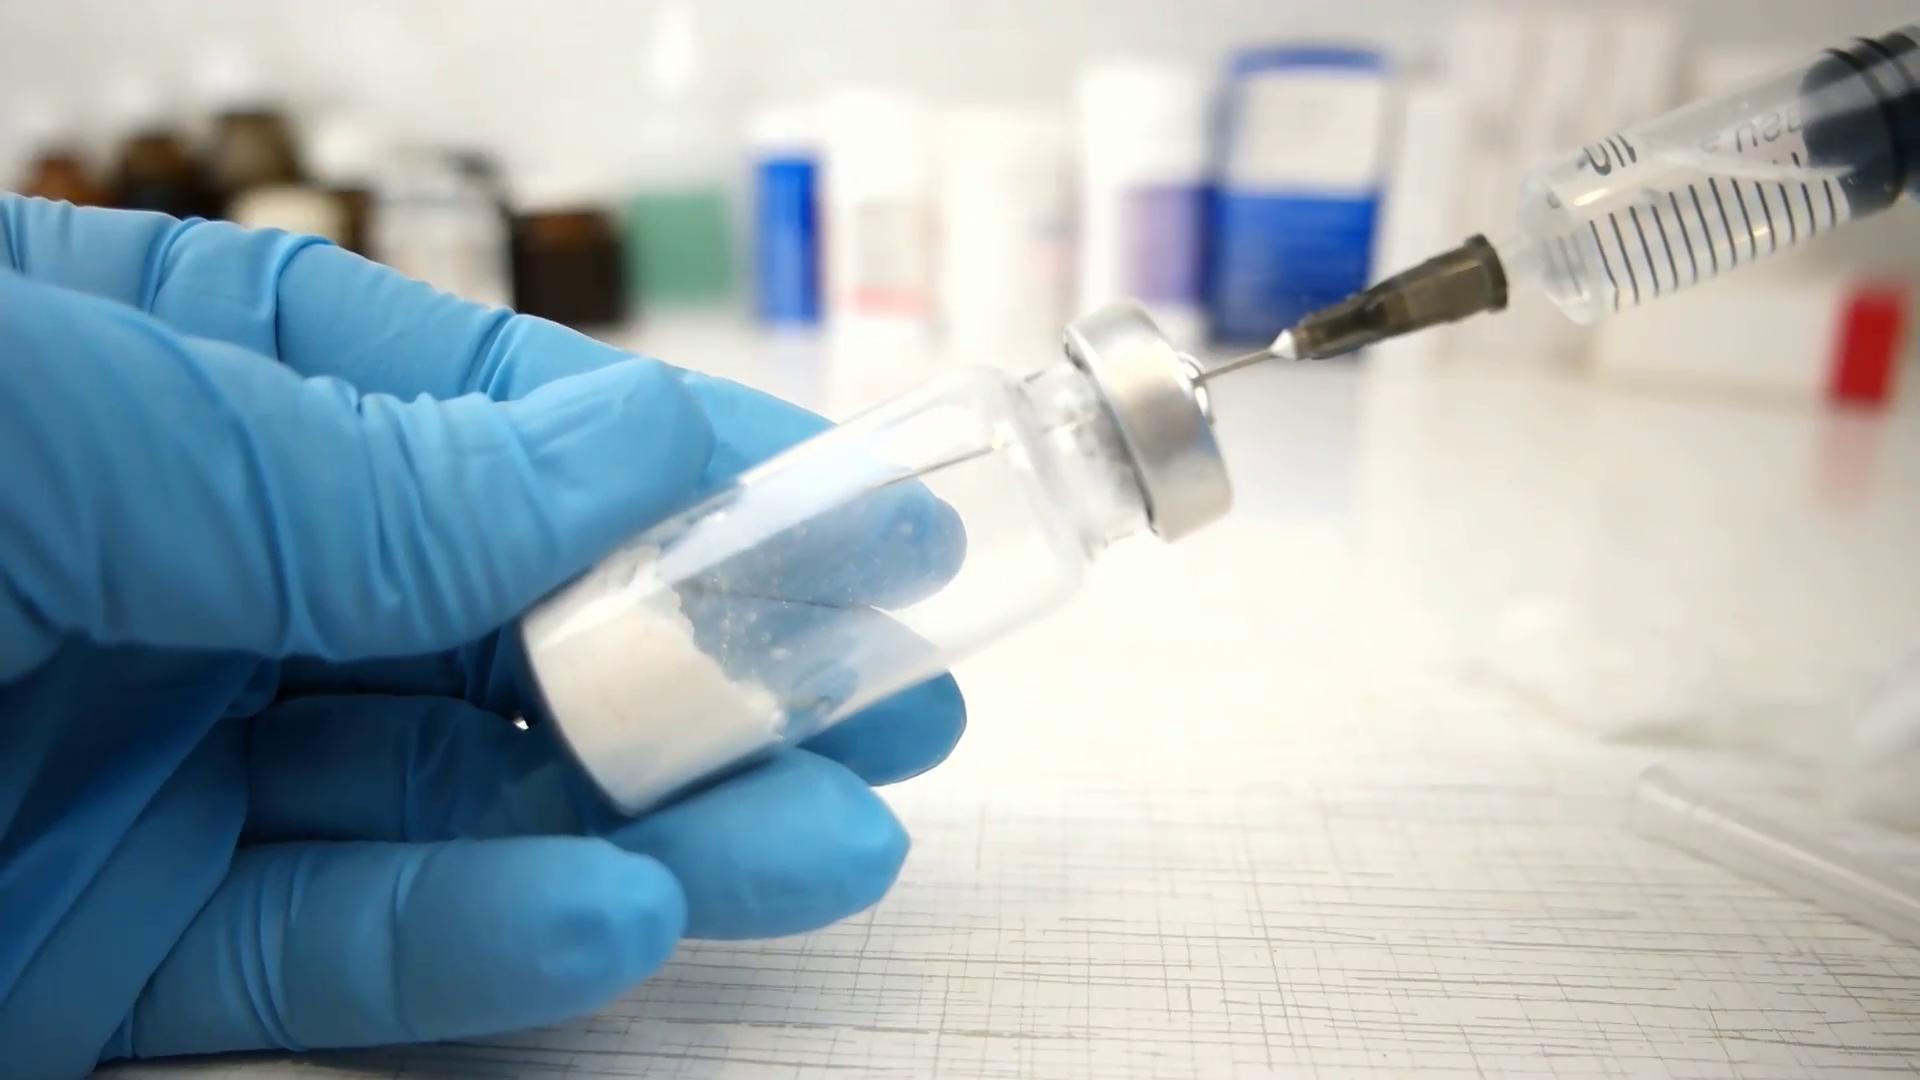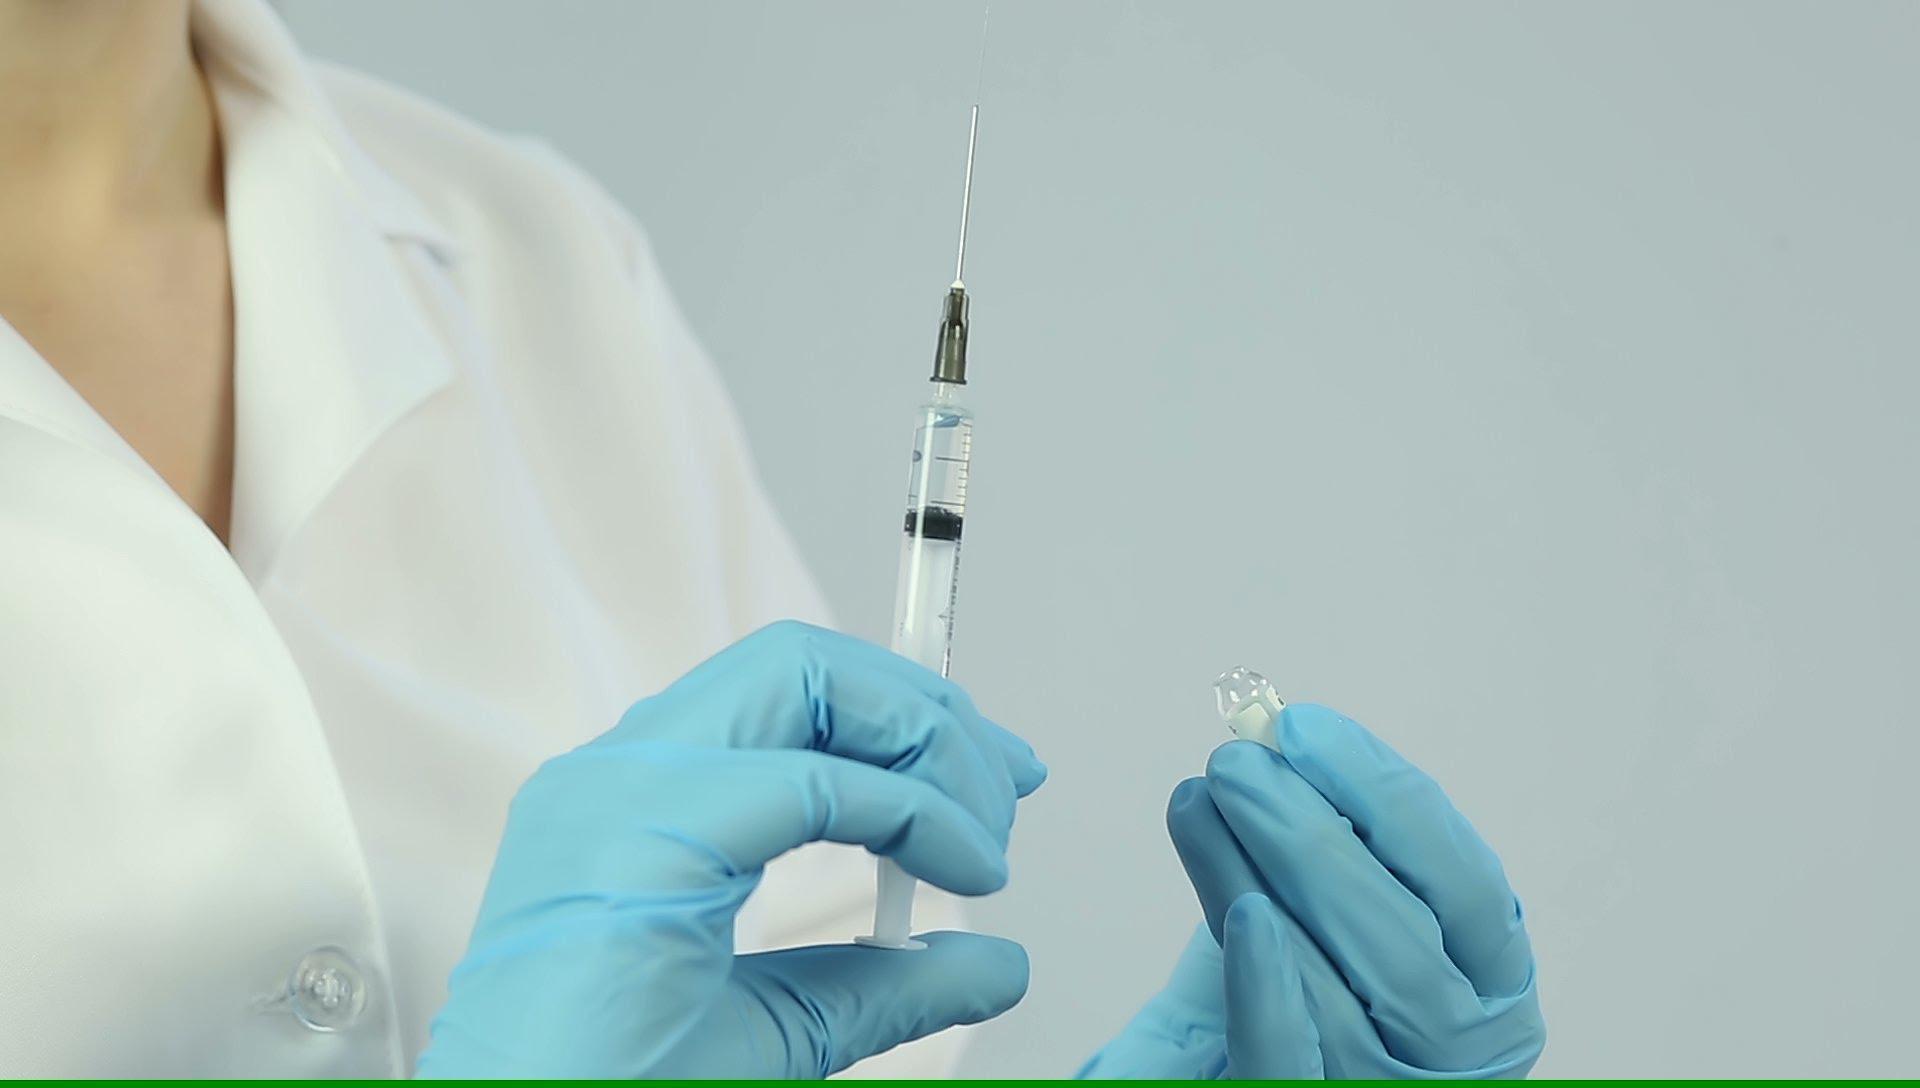The first image is the image on the left, the second image is the image on the right. Evaluate the accuracy of this statement regarding the images: "There are two needles with at least two blue gloves.". Is it true? Answer yes or no. Yes. 